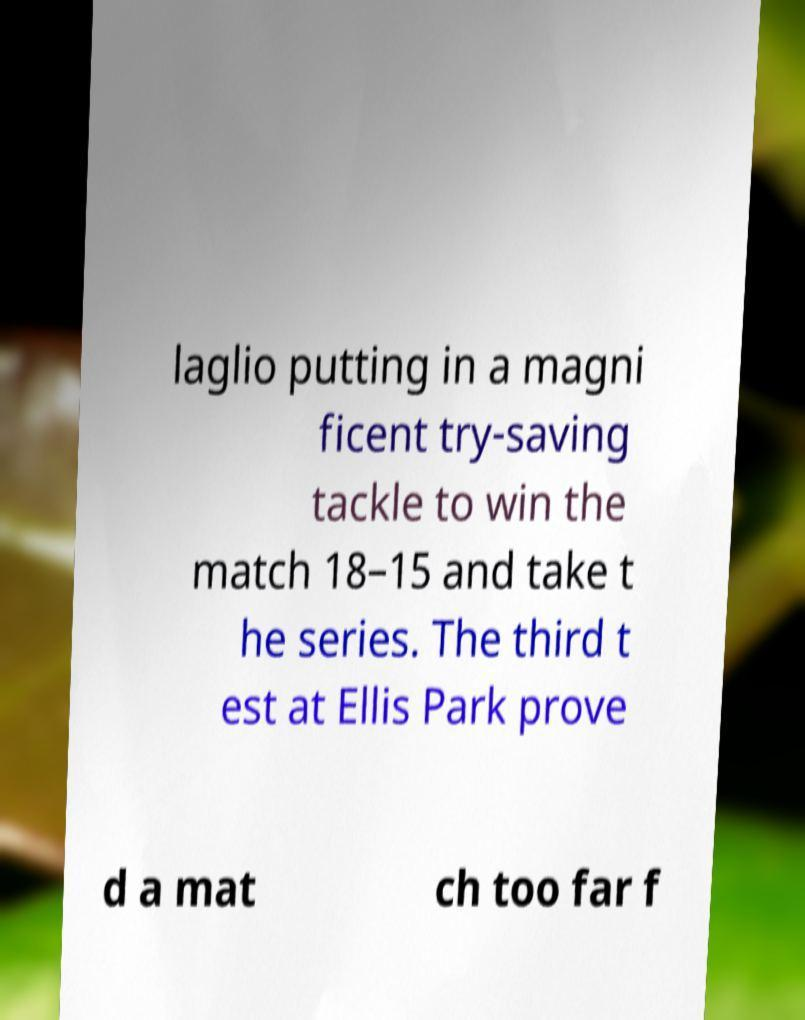Can you read and provide the text displayed in the image?This photo seems to have some interesting text. Can you extract and type it out for me? laglio putting in a magni ficent try-saving tackle to win the match 18–15 and take t he series. The third t est at Ellis Park prove d a mat ch too far f 